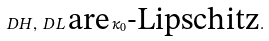Convert formula to latex. <formula><loc_0><loc_0><loc_500><loc_500>D H , \, D L \, \text {are} \, \kappa _ { 0 } \text {-Lipschitz} .</formula> 